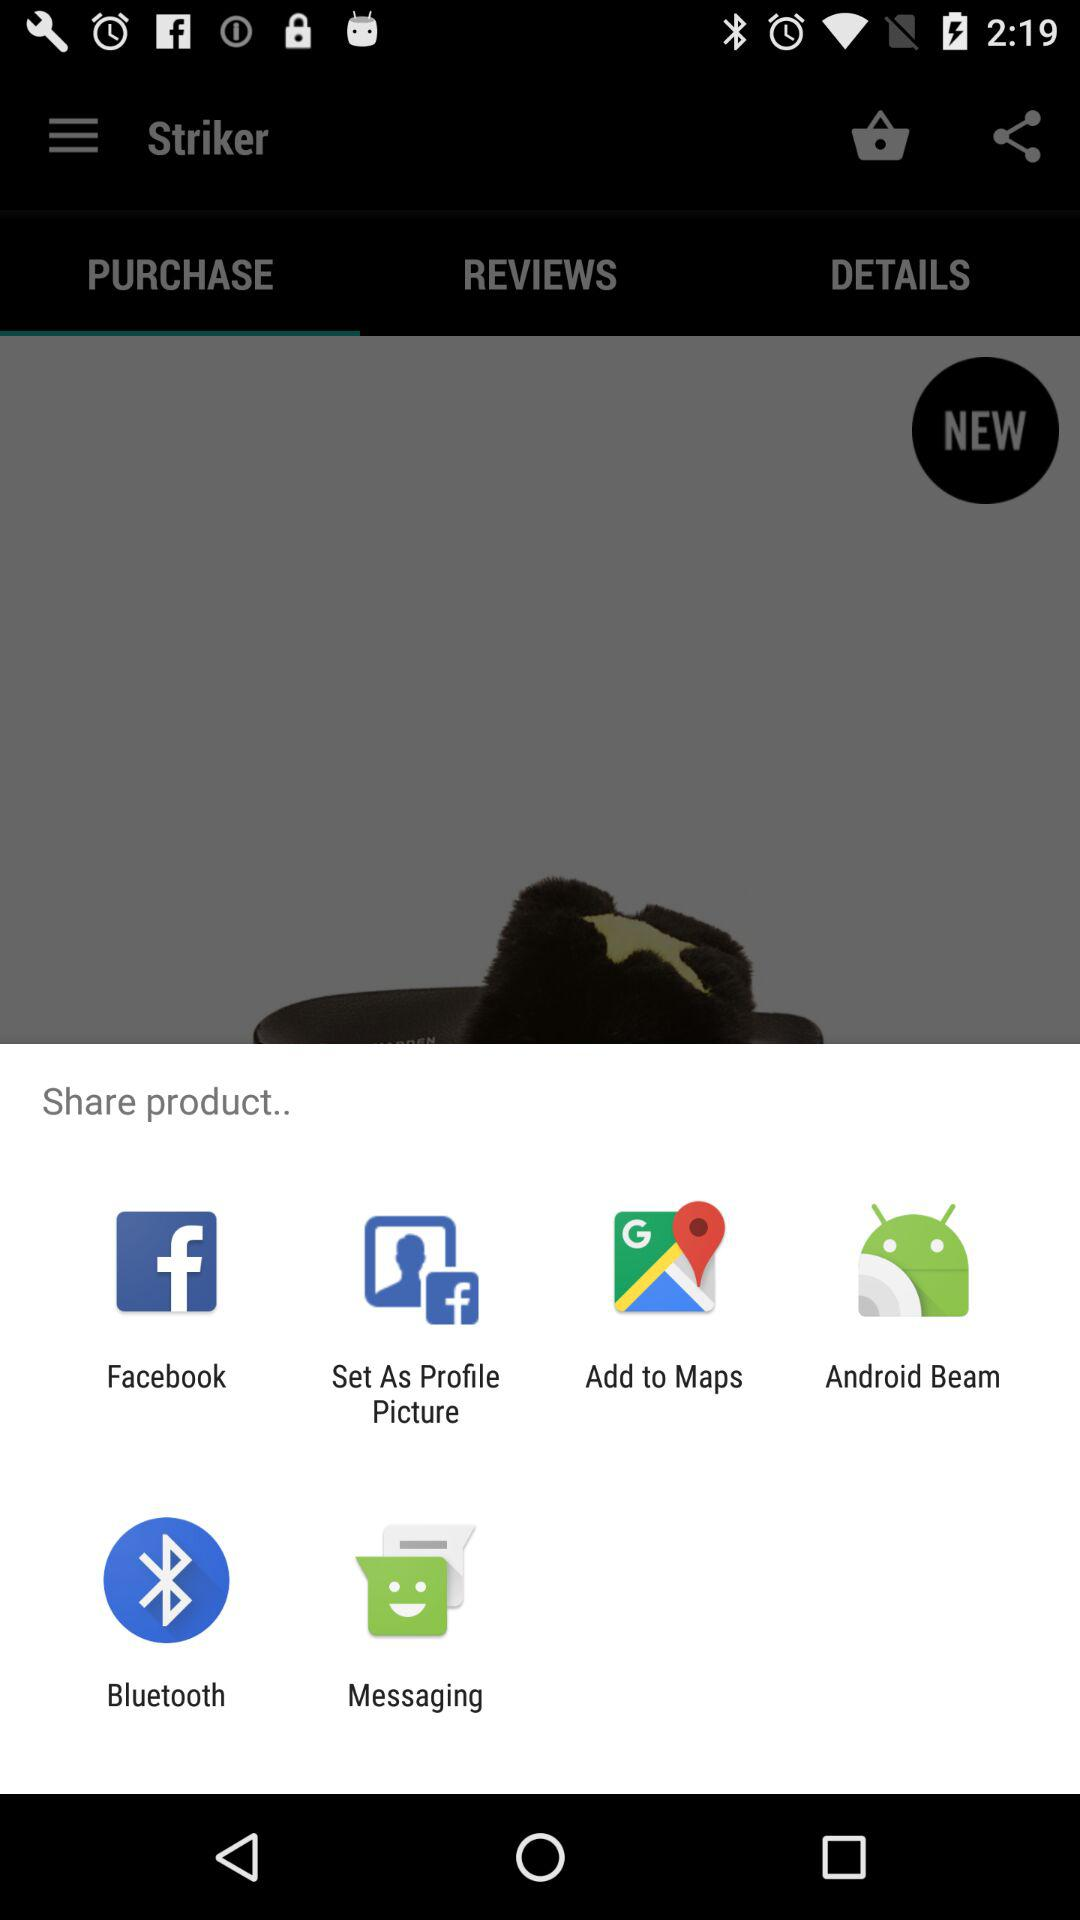When was "Striker" last updated?
When the provided information is insufficient, respond with <no answer>. <no answer> 